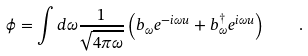<formula> <loc_0><loc_0><loc_500><loc_500>\phi = \int d \omega \frac { 1 } { \sqrt { 4 \pi \omega } } \left ( b _ { \omega } e ^ { - i \omega u } + b ^ { \dag } _ { \omega } e ^ { i \omega u } \right ) \quad .</formula> 